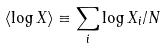<formula> <loc_0><loc_0><loc_500><loc_500>\left < \log X \right > \equiv \sum _ { i } \log X _ { i } / N</formula> 